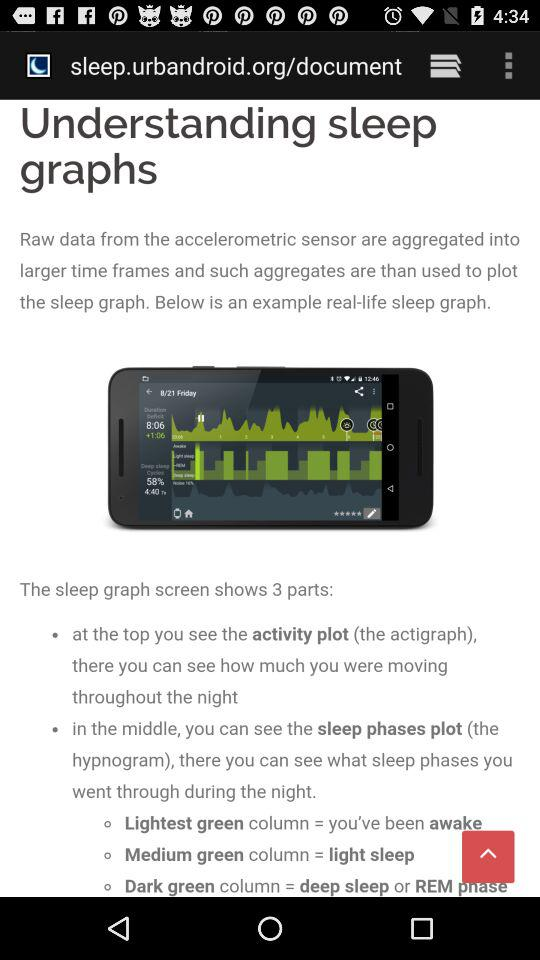Where is the plot of sleep phases located? The plot of sleep phases is located in the middle. 